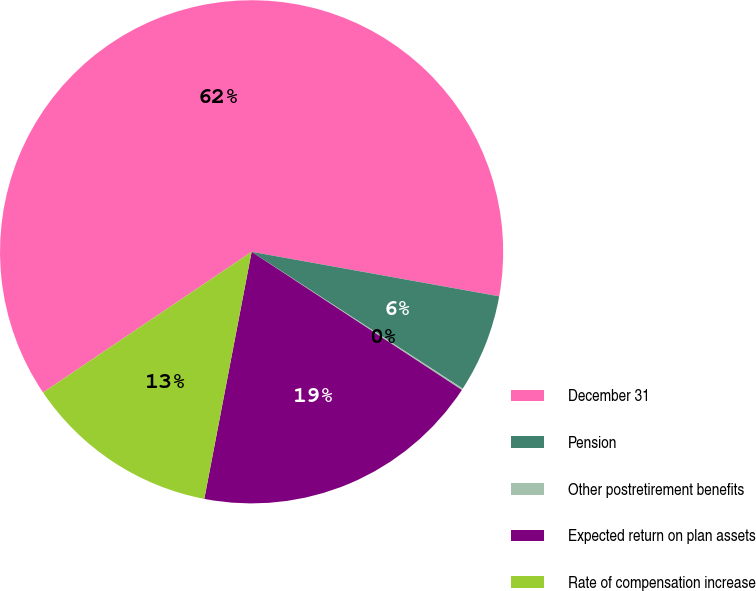Convert chart. <chart><loc_0><loc_0><loc_500><loc_500><pie_chart><fcel>December 31<fcel>Pension<fcel>Other postretirement benefits<fcel>Expected return on plan assets<fcel>Rate of compensation increase<nl><fcel>62.28%<fcel>6.32%<fcel>0.1%<fcel>18.76%<fcel>12.54%<nl></chart> 